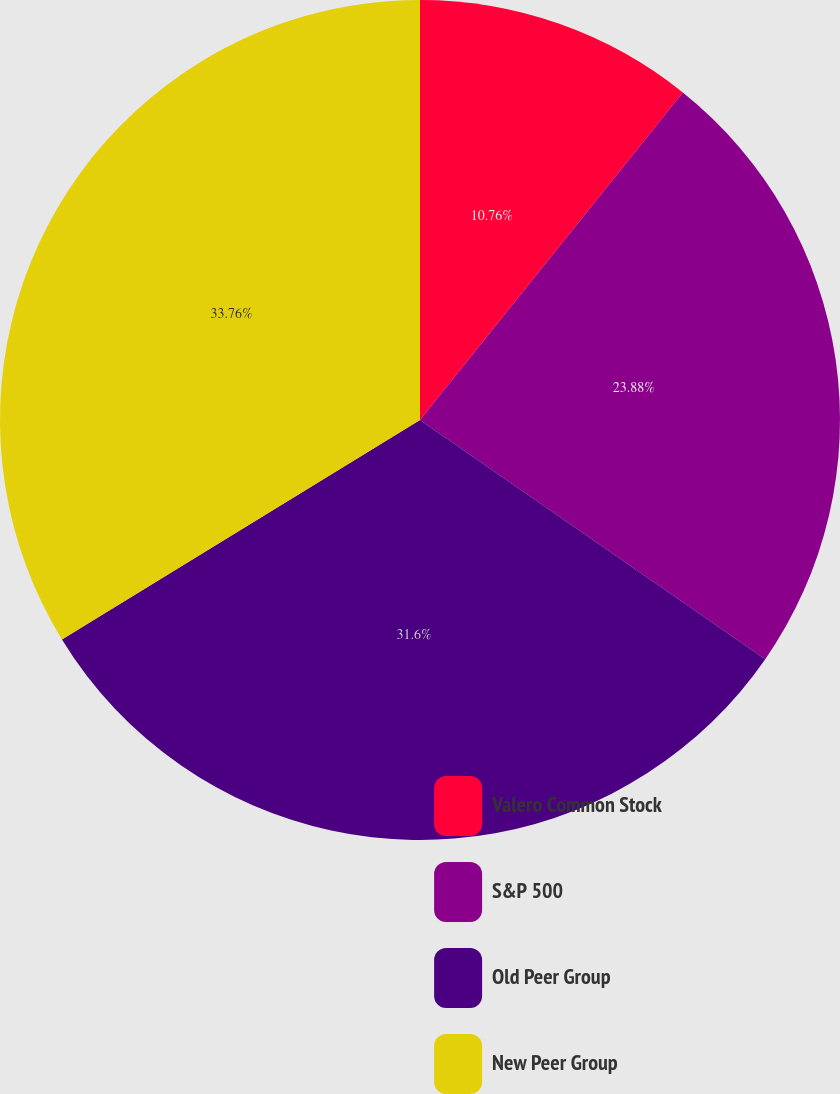<chart> <loc_0><loc_0><loc_500><loc_500><pie_chart><fcel>Valero Common Stock<fcel>S&P 500<fcel>Old Peer Group<fcel>New Peer Group<nl><fcel>10.76%<fcel>23.88%<fcel>31.6%<fcel>33.75%<nl></chart> 